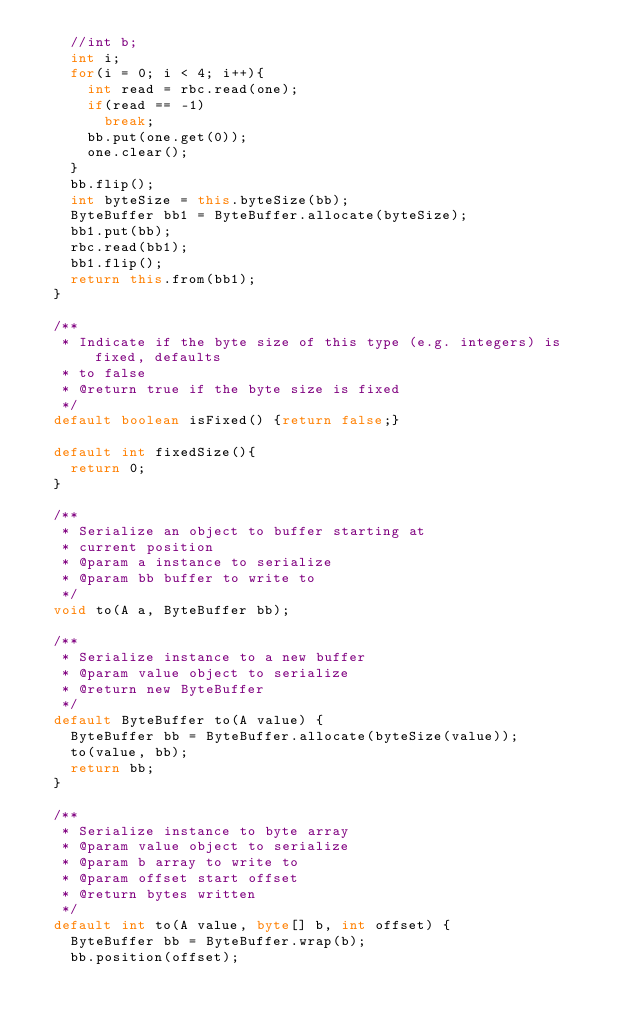<code> <loc_0><loc_0><loc_500><loc_500><_Java_>    //int b;
    int i;
    for(i = 0; i < 4; i++){
      int read = rbc.read(one);
      if(read == -1)
        break;
      bb.put(one.get(0));
      one.clear();
    }
    bb.flip();
    int byteSize = this.byteSize(bb);
    ByteBuffer bb1 = ByteBuffer.allocate(byteSize);
    bb1.put(bb);
    rbc.read(bb1);
    bb1.flip();
    return this.from(bb1);
  }

  /**
   * Indicate if the byte size of this type (e.g. integers) is fixed, defaults
   * to false
   * @return true if the byte size is fixed
   */
  default boolean isFixed() {return false;}

  default int fixedSize(){
    return 0;
  }

  /**
   * Serialize an object to buffer starting at
   * current position
   * @param a instance to serialize
   * @param bb buffer to write to
   */
  void to(A a, ByteBuffer bb);

  /**
   * Serialize instance to a new buffer
   * @param value object to serialize
   * @return new ByteBuffer
   */
  default ByteBuffer to(A value) {
    ByteBuffer bb = ByteBuffer.allocate(byteSize(value));
    to(value, bb);
    return bb;
  }

  /**
   * Serialize instance to byte array
   * @param value object to serialize
   * @param b array to write to
   * @param offset start offset
   * @return bytes written
   */
  default int to(A value, byte[] b, int offset) {
    ByteBuffer bb = ByteBuffer.wrap(b);
    bb.position(offset);</code> 